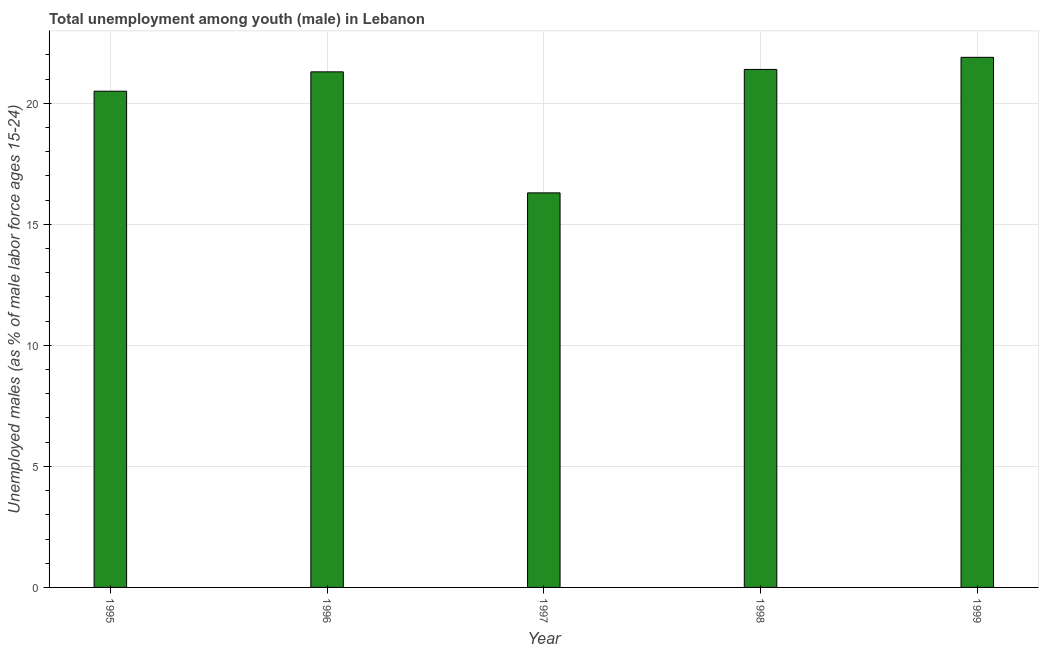Does the graph contain any zero values?
Your answer should be compact. No. What is the title of the graph?
Give a very brief answer. Total unemployment among youth (male) in Lebanon. What is the label or title of the Y-axis?
Keep it short and to the point. Unemployed males (as % of male labor force ages 15-24). What is the unemployed male youth population in 1997?
Your answer should be very brief. 16.3. Across all years, what is the maximum unemployed male youth population?
Offer a very short reply. 21.9. Across all years, what is the minimum unemployed male youth population?
Provide a short and direct response. 16.3. In which year was the unemployed male youth population minimum?
Make the answer very short. 1997. What is the sum of the unemployed male youth population?
Ensure brevity in your answer.  101.4. What is the average unemployed male youth population per year?
Ensure brevity in your answer.  20.28. What is the median unemployed male youth population?
Your response must be concise. 21.3. Do a majority of the years between 1999 and 1995 (inclusive) have unemployed male youth population greater than 18 %?
Offer a very short reply. Yes. What is the ratio of the unemployed male youth population in 1995 to that in 1997?
Offer a very short reply. 1.26. What is the difference between the highest and the second highest unemployed male youth population?
Provide a short and direct response. 0.5. What is the difference between the highest and the lowest unemployed male youth population?
Keep it short and to the point. 5.6. How many bars are there?
Offer a very short reply. 5. Are all the bars in the graph horizontal?
Ensure brevity in your answer.  No. How many years are there in the graph?
Your response must be concise. 5. What is the Unemployed males (as % of male labor force ages 15-24) in 1996?
Keep it short and to the point. 21.3. What is the Unemployed males (as % of male labor force ages 15-24) of 1997?
Give a very brief answer. 16.3. What is the Unemployed males (as % of male labor force ages 15-24) in 1998?
Provide a succinct answer. 21.4. What is the Unemployed males (as % of male labor force ages 15-24) in 1999?
Your response must be concise. 21.9. What is the difference between the Unemployed males (as % of male labor force ages 15-24) in 1995 and 1998?
Keep it short and to the point. -0.9. What is the difference between the Unemployed males (as % of male labor force ages 15-24) in 1995 and 1999?
Your answer should be very brief. -1.4. What is the difference between the Unemployed males (as % of male labor force ages 15-24) in 1996 and 1997?
Your answer should be compact. 5. What is the difference between the Unemployed males (as % of male labor force ages 15-24) in 1996 and 1999?
Keep it short and to the point. -0.6. What is the difference between the Unemployed males (as % of male labor force ages 15-24) in 1997 and 1998?
Provide a succinct answer. -5.1. What is the difference between the Unemployed males (as % of male labor force ages 15-24) in 1997 and 1999?
Your response must be concise. -5.6. What is the ratio of the Unemployed males (as % of male labor force ages 15-24) in 1995 to that in 1997?
Make the answer very short. 1.26. What is the ratio of the Unemployed males (as % of male labor force ages 15-24) in 1995 to that in 1998?
Ensure brevity in your answer.  0.96. What is the ratio of the Unemployed males (as % of male labor force ages 15-24) in 1995 to that in 1999?
Provide a short and direct response. 0.94. What is the ratio of the Unemployed males (as % of male labor force ages 15-24) in 1996 to that in 1997?
Ensure brevity in your answer.  1.31. What is the ratio of the Unemployed males (as % of male labor force ages 15-24) in 1996 to that in 1998?
Offer a very short reply. 0.99. What is the ratio of the Unemployed males (as % of male labor force ages 15-24) in 1997 to that in 1998?
Offer a terse response. 0.76. What is the ratio of the Unemployed males (as % of male labor force ages 15-24) in 1997 to that in 1999?
Ensure brevity in your answer.  0.74. 